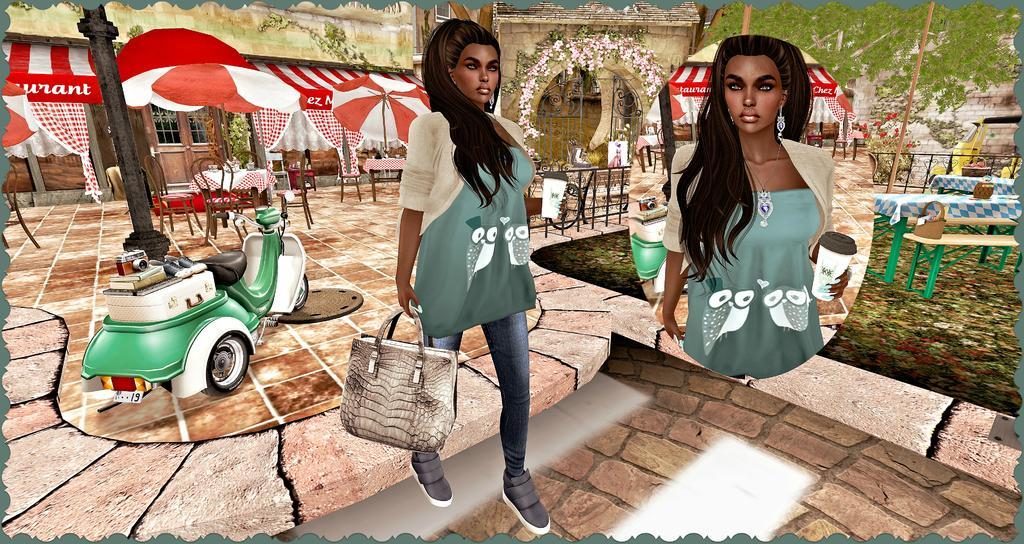How would you summarize this image in a sentence or two? In this image, we can see depiction of a person. This person is wearing clothes and holding a bag with her hand. There is a scooter and pole on the left side of the image. There are umbrellas, tables and chairs in the top left of the image. There is a building at the top of the image. There is a close view of a person in the middle of the image. There is an another table and bench on the right side of the image. 